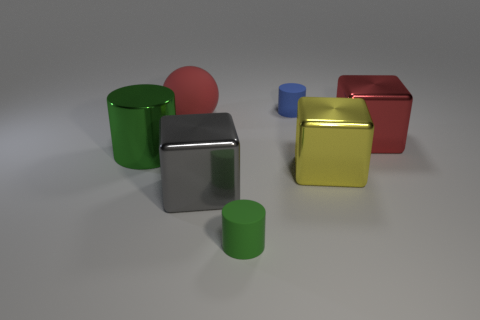Subtract all tiny rubber cylinders. How many cylinders are left? 1 Subtract all blue cylinders. How many cylinders are left? 2 Subtract 1 balls. How many balls are left? 0 Subtract all spheres. How many objects are left? 6 Subtract all brown balls. How many green cylinders are left? 2 Add 1 small green rubber cylinders. How many objects exist? 8 Add 2 metal cubes. How many metal cubes are left? 5 Add 5 big purple rubber things. How many big purple rubber things exist? 5 Subtract 0 gray balls. How many objects are left? 7 Subtract all blue cubes. Subtract all yellow spheres. How many cubes are left? 3 